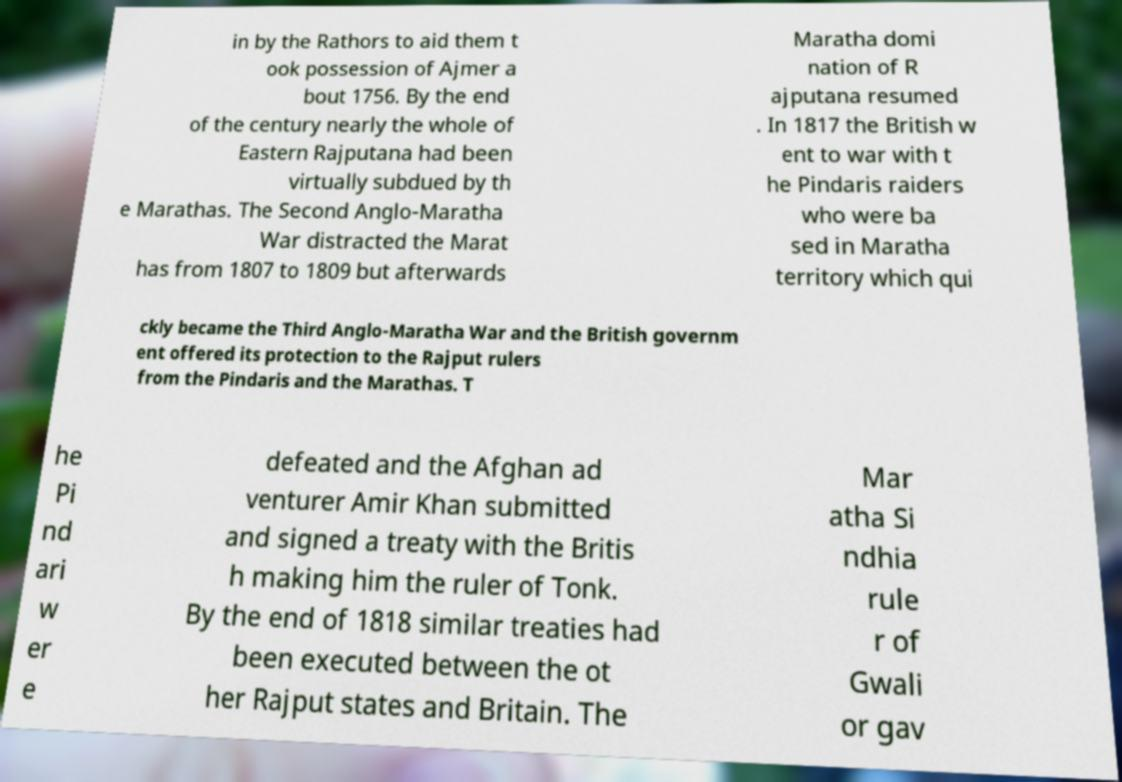What messages or text are displayed in this image? I need them in a readable, typed format. in by the Rathors to aid them t ook possession of Ajmer a bout 1756. By the end of the century nearly the whole of Eastern Rajputana had been virtually subdued by th e Marathas. The Second Anglo-Maratha War distracted the Marat has from 1807 to 1809 but afterwards Maratha domi nation of R ajputana resumed . In 1817 the British w ent to war with t he Pindaris raiders who were ba sed in Maratha territory which qui ckly became the Third Anglo-Maratha War and the British governm ent offered its protection to the Rajput rulers from the Pindaris and the Marathas. T he Pi nd ari w er e defeated and the Afghan ad venturer Amir Khan submitted and signed a treaty with the Britis h making him the ruler of Tonk. By the end of 1818 similar treaties had been executed between the ot her Rajput states and Britain. The Mar atha Si ndhia rule r of Gwali or gav 